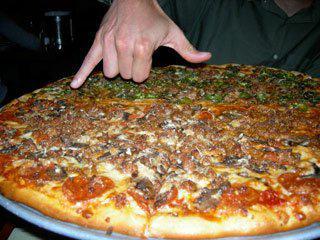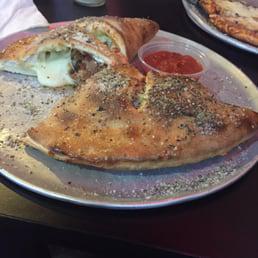The first image is the image on the left, the second image is the image on the right. Considering the images on both sides, is "The left image features a round pizza on a round metal tray, and the right image features a large round pizza in an open cardboard box with a person on the right of it." valid? Answer yes or no. No. The first image is the image on the left, the second image is the image on the right. Analyze the images presented: Is the assertion "There are two whole pizzas." valid? Answer yes or no. No. 